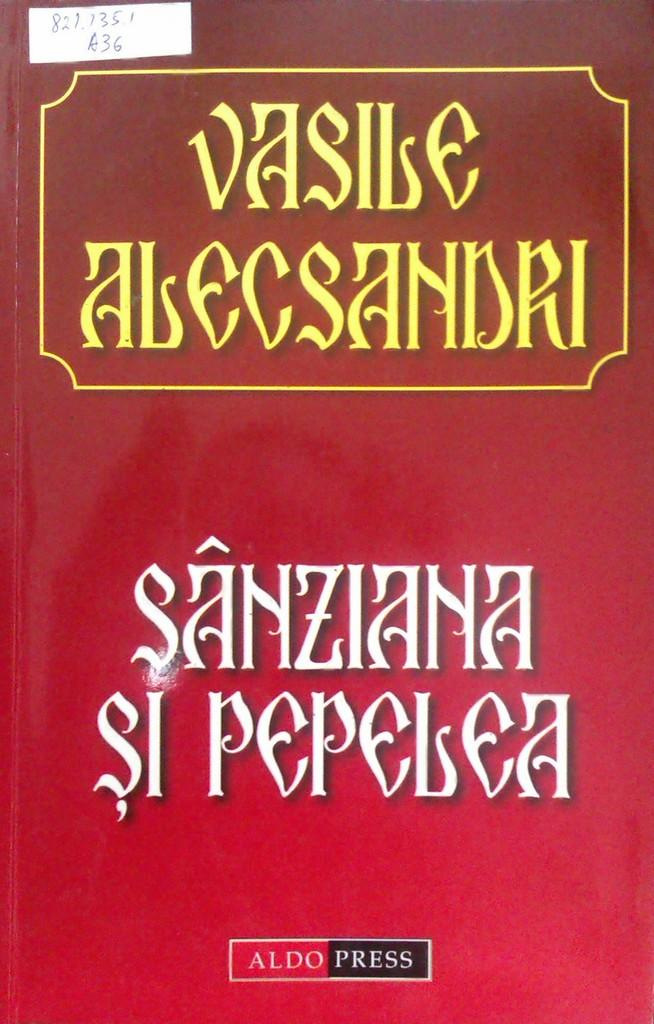<image>
Share a concise interpretation of the image provided. A red book titled Vasile Alecsandri in yellow text. 